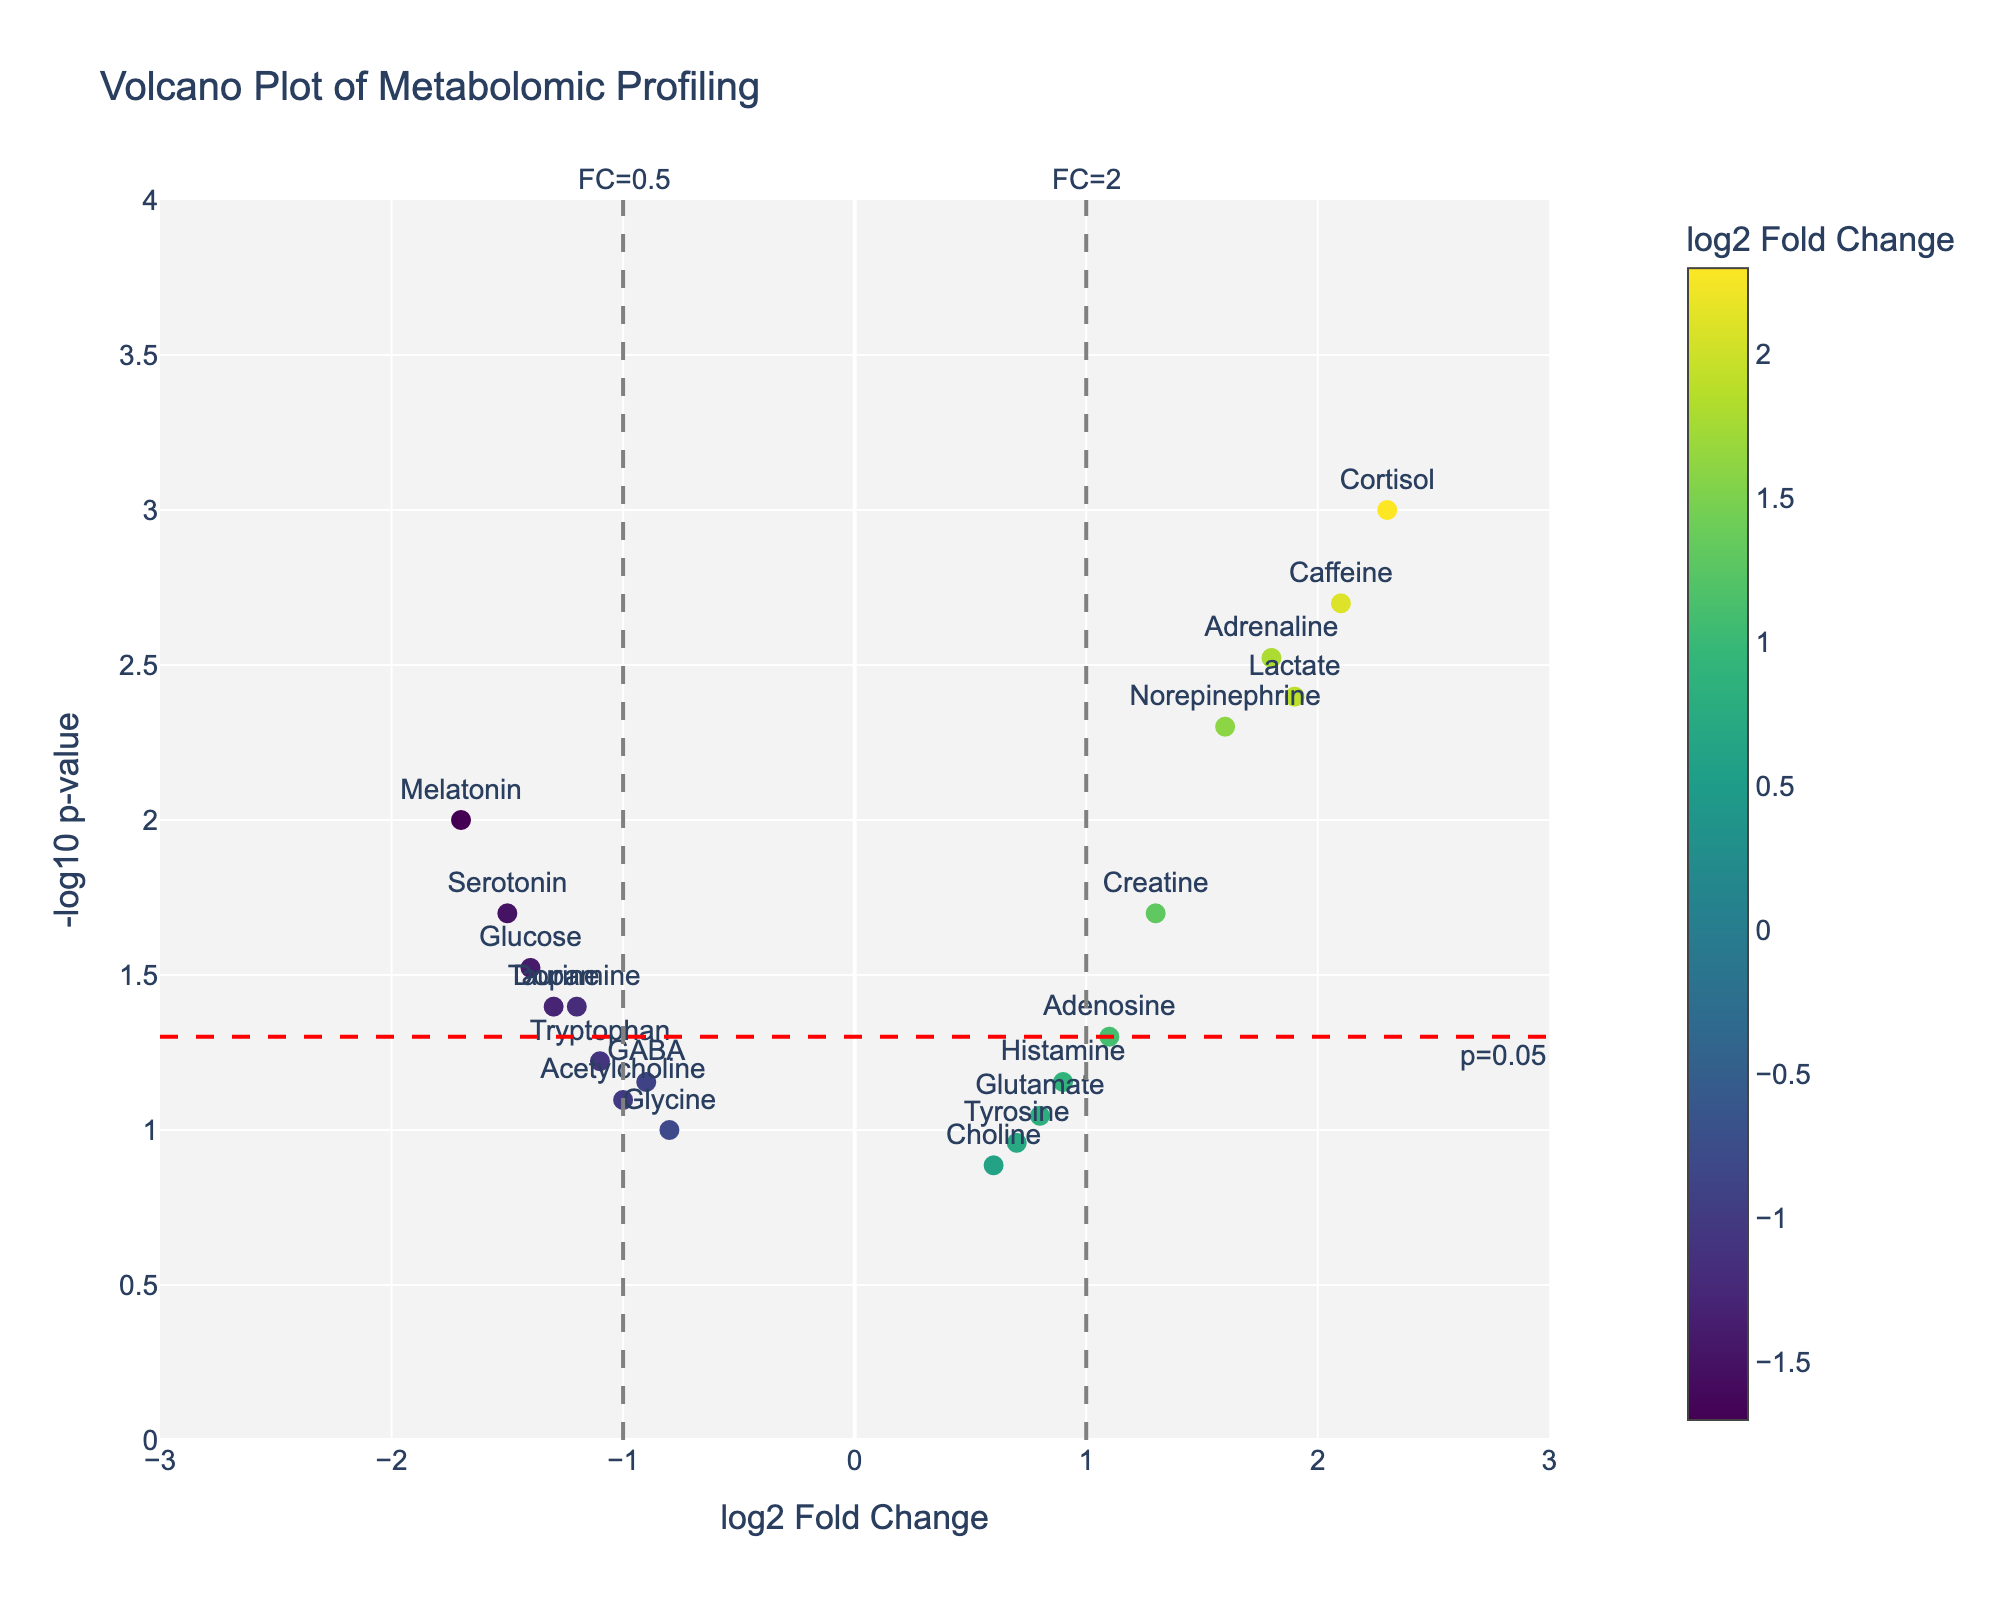Which metabolite shows the highest log2 fold change? Cortisol shows the highest log2 fold change, indicated by being the farthest point to the right on the x-axis (log2 FC: 2.3).
Answer: Cortisol Which metabolite has the smallest p-value? A smaller p-value corresponds to a higher -log10(p-value). The highest point on the y-axis is for Cortisol (p-value: 0.001).
Answer: Cortisol Which metabolites are significantly altered with a p-value less than 0.05 and a log2 fold change greater than 1? Metabolites that meet the criteria are above the red horizontal line (-log10(p-value) > 1.3) and to the right of the gray vertical line (log2 FC > 1). These include Cortisol, Adrenaline, Norepinephrine, Lactate, and Caffeine.
Answer: Cortisol, Adrenaline, Norepinephrine, Lactate, Caffeine Which metabolite with a log2 fold change less than -1 has the smallest p-value? Of the metabolites with a log2 fold change less than -1 (left of the left vertical gray line), Melatonin has the smallest p-value (highest -log10(p-value)).
Answer: Melatonin How many metabolites have a log2 fold change between -1 and 1 and a p-value greater than 0.05? These are within the vertical gray lines and below the red horizontal line. They include GABA, Glutamate, Tryptophan, Tyrosine, Choline, Acetylcholine, Adenosine, Histamine, Glycine.
Answer: 9 What is the primary color range used in the plot for the markers? The plot uses a gradient color scheme ranging from purple to yellow, reflecting the Viridis color scale based on log2 fold change values.
Answer: Purple to yellow Which metabolite associated with an increased log2 fold change also has a significant p-value (less than 0.05), but with a fold change less than 2? Creatine falls within this range with a log2 fold change of 1.3 and a p-value of 0.02.
Answer: Creatine How is significance indicated on the plot? Significance is indicated by the horizontal red dashed line at -log10(p-value) = 1.3, representing p-value = 0.05. Points above this line are considered significant.
Answer: By a red dashed line at -log10(p-value) = 1.3 (p-value = 0.05) Which metabolite has a log2 fold change close to zero but is not considered significant? Choline, with a log2 fold change of 0.6 and p-value of 0.13, is close to zero but below the significance threshold.
Answer: Choline 